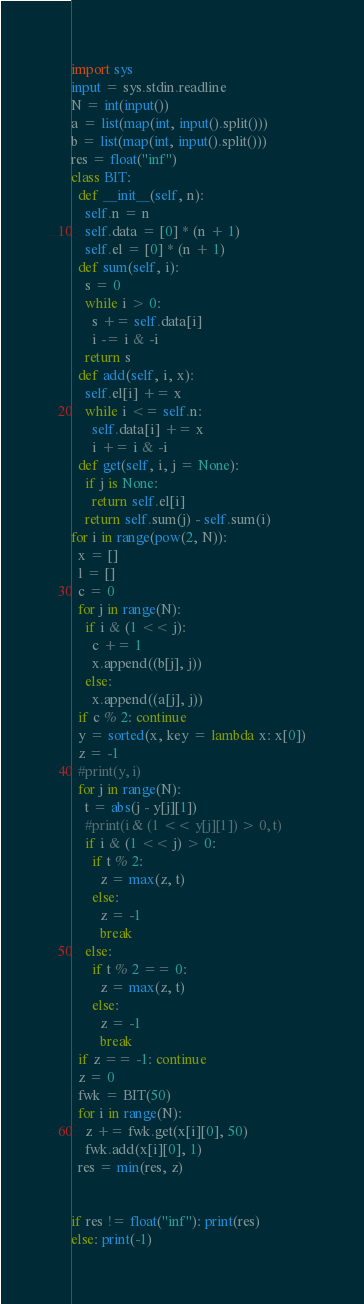Convert code to text. <code><loc_0><loc_0><loc_500><loc_500><_Python_>import sys
input = sys.stdin.readline
N = int(input())
a = list(map(int, input().split()))
b = list(map(int, input().split()))
res = float("inf")
class BIT:
  def __init__(self, n):
    self.n = n
    self.data = [0] * (n + 1)
    self.el = [0] * (n + 1)
  def sum(self, i):
    s = 0
    while i > 0:
      s += self.data[i]
      i -= i & -i
    return s
  def add(self, i, x):
    self.el[i] += x
    while i <= self.n:
      self.data[i] += x
      i += i & -i
  def get(self, i, j = None):
    if j is None:
      return self.el[i]
    return self.sum(j) - self.sum(i)
for i in range(pow(2, N)):
  x = []
  l = []
  c = 0
  for j in range(N):
    if i & (1 << j):
      c += 1
      x.append((b[j], j))
    else:
      x.append((a[j], j))
  if c % 2: continue
  y = sorted(x, key = lambda x: x[0])
  z = -1
  #print(y, i)
  for j in range(N):
    t = abs(j - y[j][1])
    #print(i & (1 << y[j][1]) > 0, t)
    if i & (1 << j) > 0:
      if t % 2:
        z = max(z, t)
      else:
        z = -1
        break
    else:
      if t % 2 == 0:
        z = max(z, t)
      else:
        z = -1
        break
  if z == -1: continue
  z = 0
  fwk = BIT(50)
  for i in range(N):
    z += fwk.get(x[i][0], 50)
    fwk.add(x[i][0], 1)
  res = min(res, z)

  
if res != float("inf"): print(res)
else: print(-1)</code> 